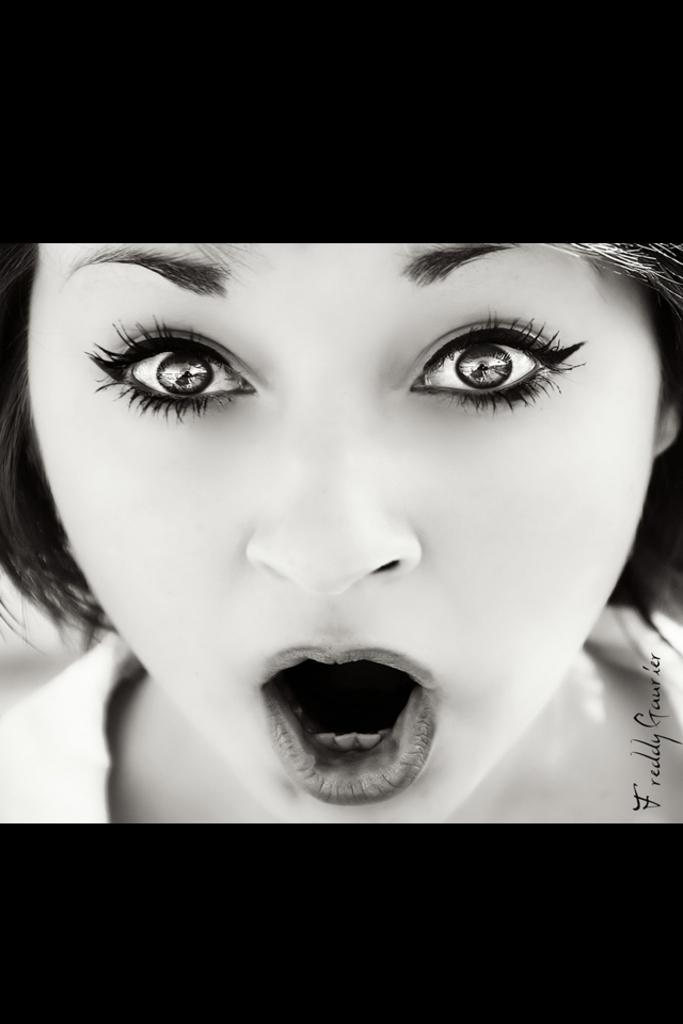What is the main subject of the image? The main subject of the image is a girl. What is the girl doing in the image? The girl is shouting and giving a pose. How is the girl positioned in relation to the camera? The girl is facing the camera. What type of legal advice is the girl providing in the image? There is no indication in the image that the girl is providing any legal advice, as she is shouting and giving a pose. What type of social event is the girl attending in the image? There is no indication in the image of a specific social event; the girl is simply shouting and giving a pose. 